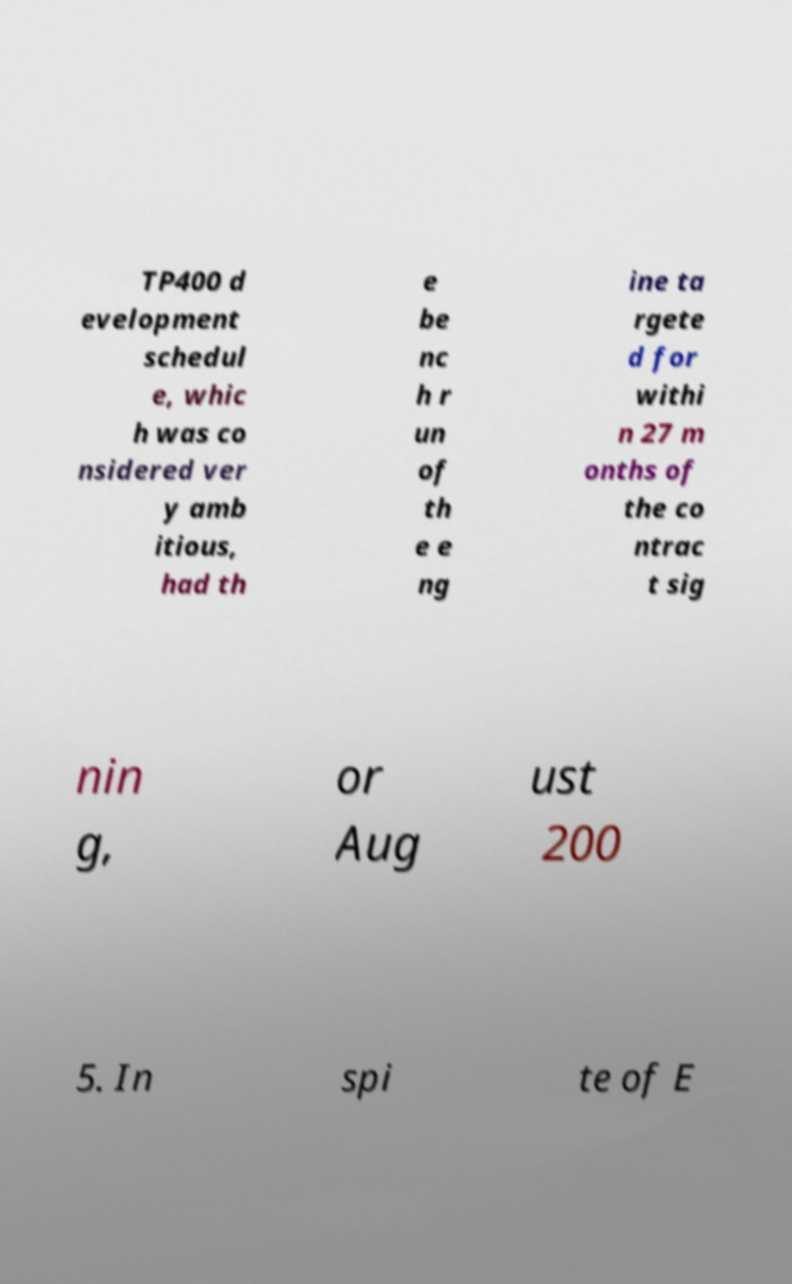Could you extract and type out the text from this image? TP400 d evelopment schedul e, whic h was co nsidered ver y amb itious, had th e be nc h r un of th e e ng ine ta rgete d for withi n 27 m onths of the co ntrac t sig nin g, or Aug ust 200 5. In spi te of E 